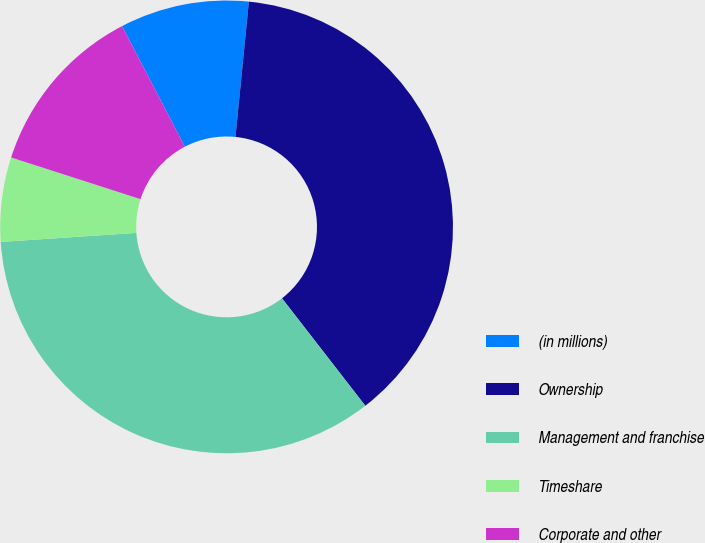Convert chart to OTSL. <chart><loc_0><loc_0><loc_500><loc_500><pie_chart><fcel>(in millions)<fcel>Ownership<fcel>Management and franchise<fcel>Timeshare<fcel>Corporate and other<nl><fcel>9.21%<fcel>37.93%<fcel>34.44%<fcel>6.02%<fcel>12.4%<nl></chart> 